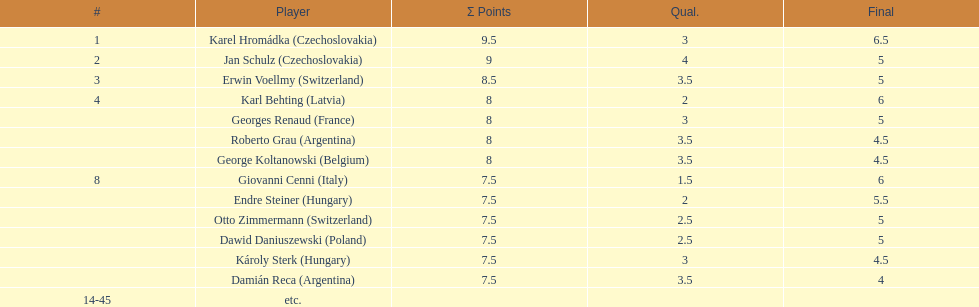From switzerland, who scored the most points? Erwin Voellmy. 